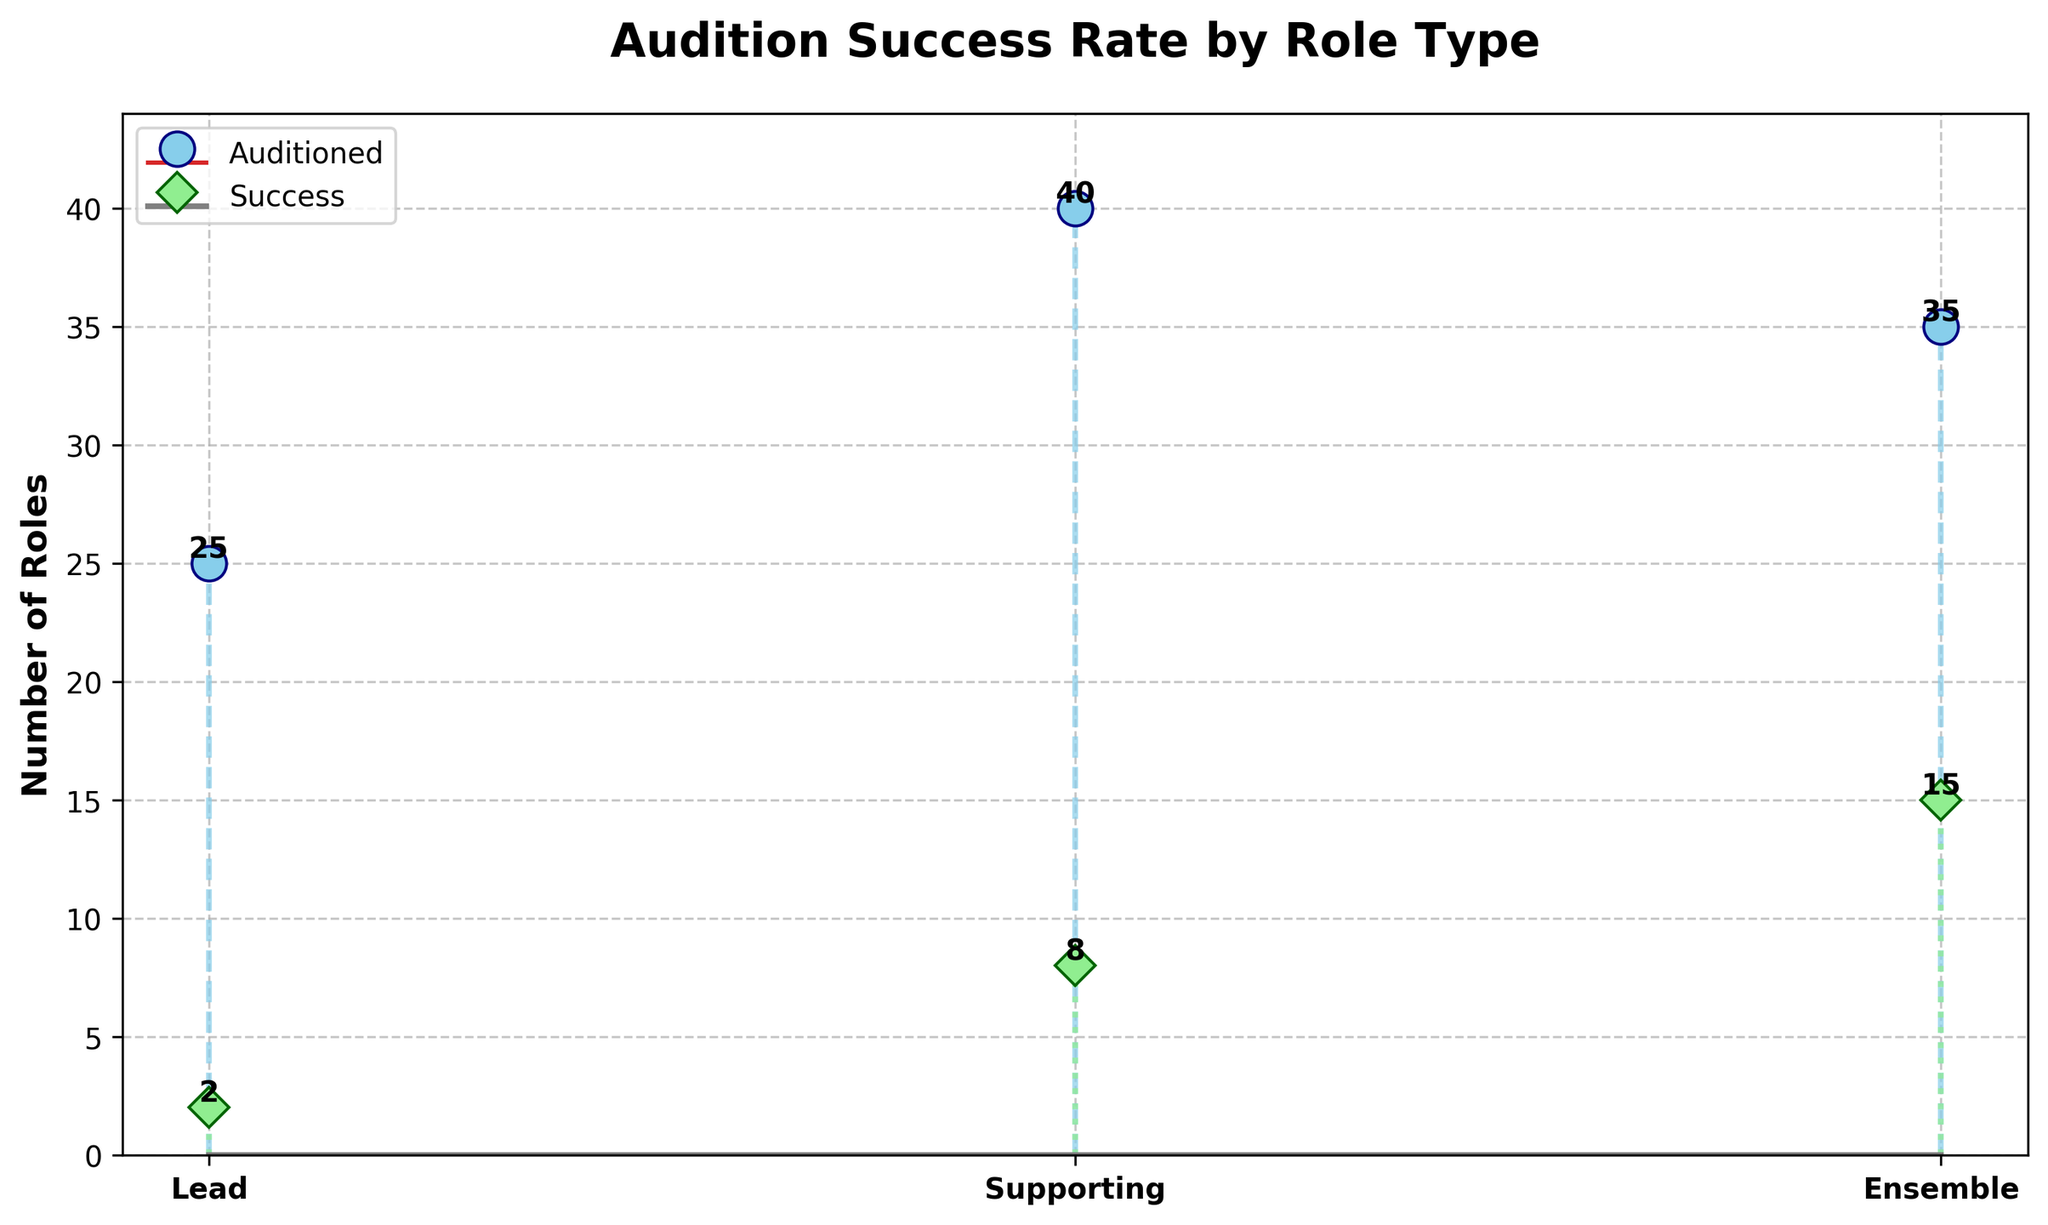How many types of roles are shown in the figure? The X-axis lists different types of roles. Each unique tick on the X-axis corresponds to a type of role. Here we notice three labels: Lead, Supporting, and Ensemble.
Answer: Three What is the title of the figure? The title of the figure is usually located at the top, in bold text. In this case, it reads "Audition Success Rate by Role Type".
Answer: Audition Success Rate by Role Type Which role has the highest number of successful auditions? By observing the labeled stems on the plot, we note the number of successful auditions for each role. Ensemble has the tallest stem in the success category with 15 successes.
Answer: Ensemble What are the total auditions attended for supporting and lead roles? From the stems corresponding to Supporting and Lead on the 'Auditioned' line, we add 40 (Supporting) + 25 (Lead) = 65.
Answer: 65 Which role has the lowest success rate? Success rate can be calculated by the ratio of successes to auditions. Lead has 2 successes out of 25 auditions, which is the lowest ratio (2/25 = 0.08).
Answer: Lead Compare the number of auditions and successes for the Ensemble role. The plot shows that Ensemble has 35 auditions (top of the stem marked "Ensemble") and 15 successes (top of the success stem marked "Ensemble").
Answer: 35 auditions, 15 successes What is the visual difference in markers between auditioned and successful roles? The auditioned markers are circles (o) colored sky blue, whereas the success markers are diamonds (D) colored light green.
Answer: Circle (sky blue) for auditioned, Diamond (light green) for success Which role has the greatest difference between auditioned and successes? By subtracting the number of successful auditions from the total auditions for each role: Lead (25-2=23), Supporting (40-8=32), Ensemble (35-15=20). Supporting has the greatest difference, which is 32.
Answer: Supporting What is the ratio of successful auditions to total auditions across all roles? Summing all auditions (25+40+35=100) and all successes (2+8+15=25), then calculating the ratio (25/100 = 0.25).
Answer: 0.25 How many more successful auditions does the least successful role need to equal the successes of the second most successful role? Lead has 2 successes and Supporting has 8. To equal Supporting, Lead needs 6 more successes (8-2=6).
Answer: 6 